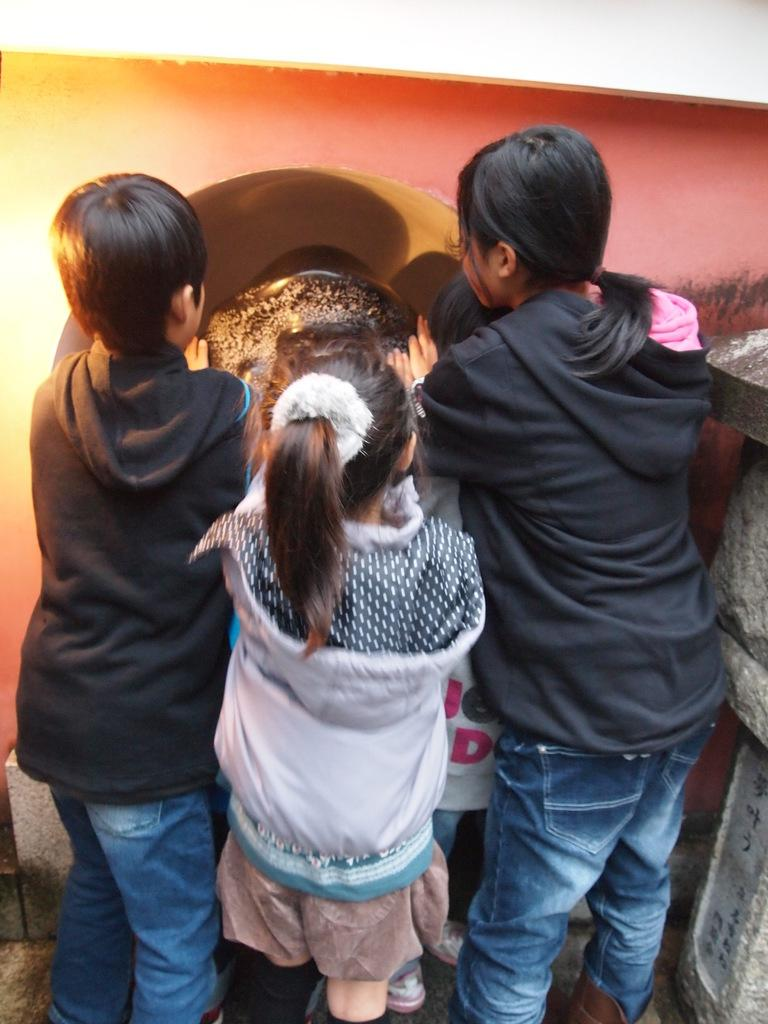Who is present in the image? There are kids in the image. What are the kids doing in the image? The kids are standing at a wall. What type of vest is the apple wearing in the image? There is no apple or vest present in the image. 